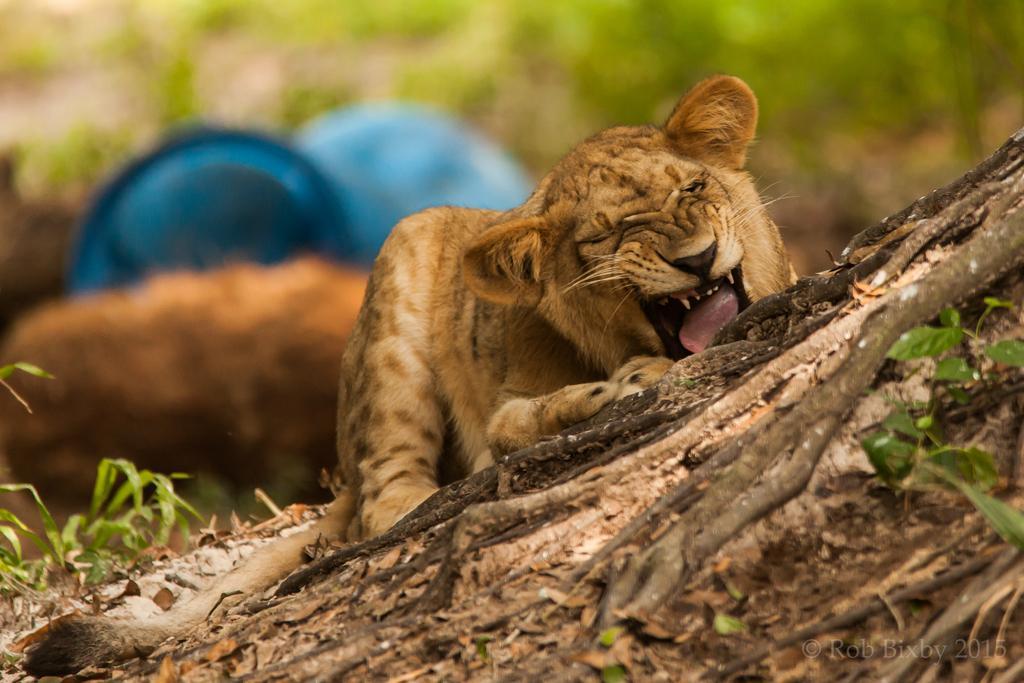In one or two sentences, can you explain what this image depicts? In this image I can see grass and here I can see a cream colour female lion. I can also see few blue colour things in background and I can see this image is little bit blurry from background. 